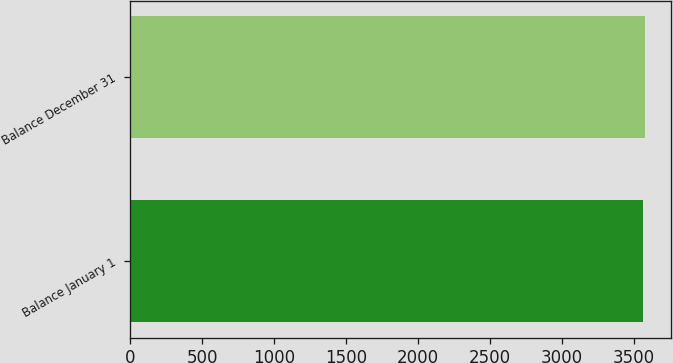Convert chart. <chart><loc_0><loc_0><loc_500><loc_500><bar_chart><fcel>Balance January 1<fcel>Balance December 31<nl><fcel>3563<fcel>3577<nl></chart> 